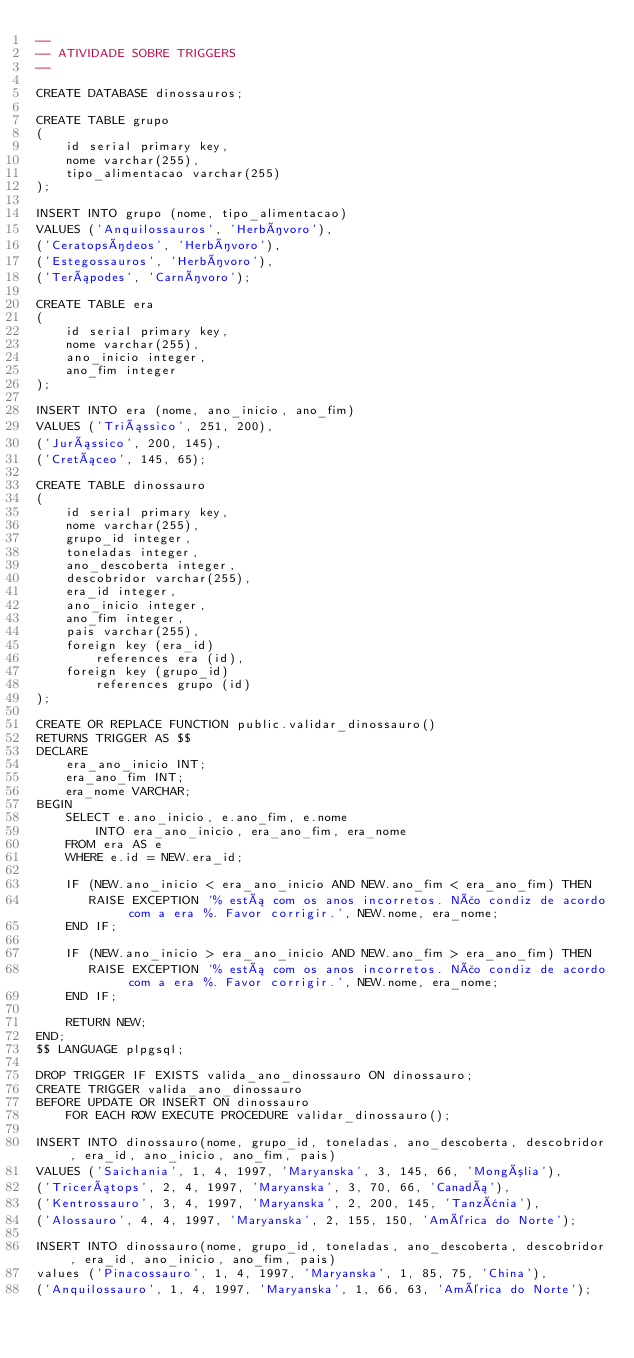<code> <loc_0><loc_0><loc_500><loc_500><_SQL_>--
-- ATIVIDADE SOBRE TRIGGERS
-- 

CREATE DATABASE dinossauros;

CREATE TABLE grupo
(
	id serial primary key,
	nome varchar(255),
	tipo_alimentacao varchar(255)
);

INSERT INTO grupo (nome, tipo_alimentacao)
VALUES ('Anquilossauros', 'Herbívoro'),
('Ceratopsídeos', 'Herbívoro'),
('Estegossauros', 'Herbívoro'),
('Terápodes', 'Carnívoro');

CREATE TABLE era
(
	id serial primary key,
	nome varchar(255),
	ano_inicio integer,
	ano_fim integer
);

INSERT INTO era (nome, ano_inicio, ano_fim)
VALUES ('Triássico', 251, 200),
('Jurássico', 200, 145),
('Cretáceo', 145, 65);

CREATE TABLE dinossauro
(
	id serial primary key,
	nome varchar(255),
	grupo_id integer,
	toneladas integer,
	ano_descoberta integer,
	descobridor varchar(255),
	era_id integer,
	ano_inicio integer,
	ano_fim integer,
	pais varchar(255),
	foreign key (era_id)
    	references era (id),
    foreign key (grupo_id)
    	references grupo (id)
);

CREATE OR REPLACE FUNCTION public.validar_dinossauro()
RETURNS TRIGGER AS $$
DECLARE 
	era_ano_inicio INT;
	era_ano_fim INT;
    era_nome VARCHAR;
BEGIN
	SELECT e.ano_inicio, e.ano_fim, e.nome
		INTO era_ano_inicio, era_ano_fim, era_nome
	FROM era AS e
	WHERE e.id = NEW.era_id;
	
    IF (NEW.ano_inicio < era_ano_inicio AND NEW.ano_fim < era_ano_fim) THEN
       RAISE EXCEPTION '% está com os anos incorretos. Não condiz de acordo com a era %. Favor corrigir.', NEW.nome, era_nome;
    END IF;
   
   	IF (NEW.ano_inicio > era_ano_inicio AND NEW.ano_fim > era_ano_fim) THEN
       RAISE EXCEPTION '% está com os anos incorretos. Não condiz de acordo com a era %. Favor corrigir.', NEW.nome, era_nome;
    END IF;
   
    RETURN NEW;
END;
$$ LANGUAGE plpgsql;

DROP TRIGGER IF EXISTS valida_ano_dinossauro ON dinossauro;
CREATE TRIGGER valida_ano_dinossauro 
BEFORE UPDATE OR INSERT ON dinossauro 
	FOR EACH ROW EXECUTE PROCEDURE validar_dinossauro();

INSERT INTO dinossauro(nome, grupo_id, toneladas, ano_descoberta, descobridor, era_id, ano_inicio, ano_fim, pais)
VALUES ('Saichania', 1, 4, 1997, 'Maryanska', 3, 145, 66, 'Mongólia'),
('Tricerátops', 2, 4, 1997, 'Maryanska', 3, 70, 66, 'Canadá'),
('Kentrossauro', 3, 4, 1997, 'Maryanska', 2, 200, 145, 'Tanzânia'),
('Alossauro', 4, 4, 1997, 'Maryanska', 2, 155, 150, 'América do Norte');

INSERT INTO dinossauro(nome, grupo_id, toneladas, ano_descoberta, descobridor, era_id, ano_inicio, ano_fim, pais)
values ('Pinacossauro', 1, 4, 1997, 'Maryanska', 1, 85, 75, 'China'),
('Anquilossauro', 1, 4, 1997, 'Maryanska', 1, 66, 63, 'América do Norte');</code> 